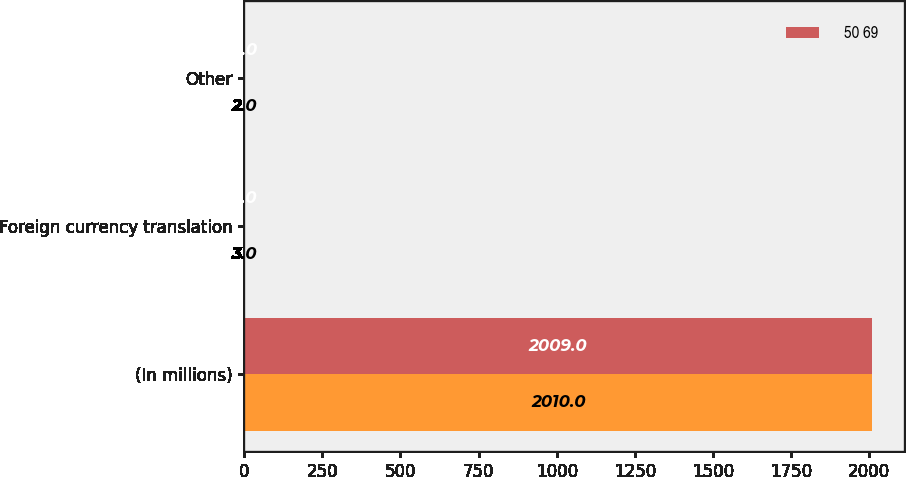Convert chart to OTSL. <chart><loc_0><loc_0><loc_500><loc_500><stacked_bar_chart><ecel><fcel>(In millions)<fcel>Foreign currency translation<fcel>Other<nl><fcel>nan<fcel>2010<fcel>3<fcel>2<nl><fcel>50 69<fcel>2009<fcel>2<fcel>4<nl></chart> 